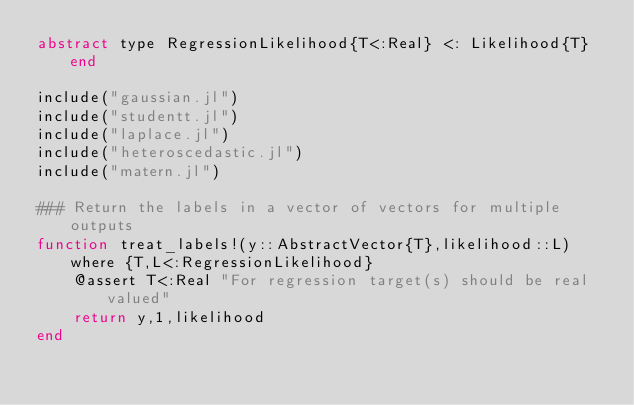<code> <loc_0><loc_0><loc_500><loc_500><_Julia_>abstract type RegressionLikelihood{T<:Real} <: Likelihood{T} end

include("gaussian.jl")
include("studentt.jl")
include("laplace.jl")
include("heteroscedastic.jl")
include("matern.jl")

### Return the labels in a vector of vectors for multiple outputs
function treat_labels!(y::AbstractVector{T},likelihood::L) where {T,L<:RegressionLikelihood}
    @assert T<:Real "For regression target(s) should be real valued"
    return y,1,likelihood
end
</code> 